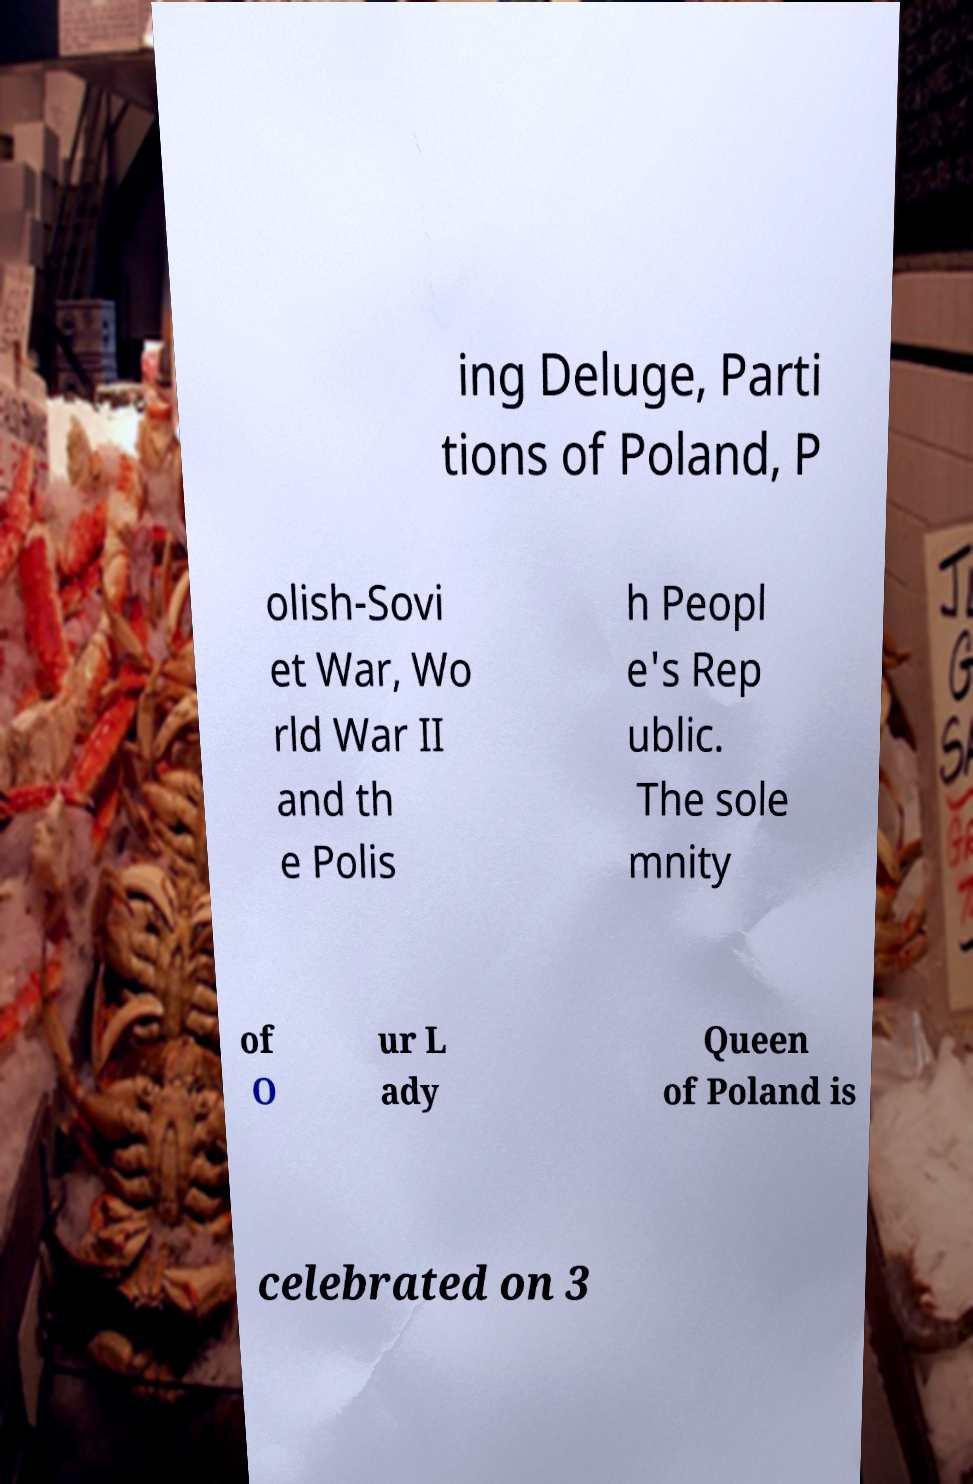What messages or text are displayed in this image? I need them in a readable, typed format. ing Deluge, Parti tions of Poland, P olish-Sovi et War, Wo rld War II and th e Polis h Peopl e's Rep ublic. The sole mnity of O ur L ady Queen of Poland is celebrated on 3 